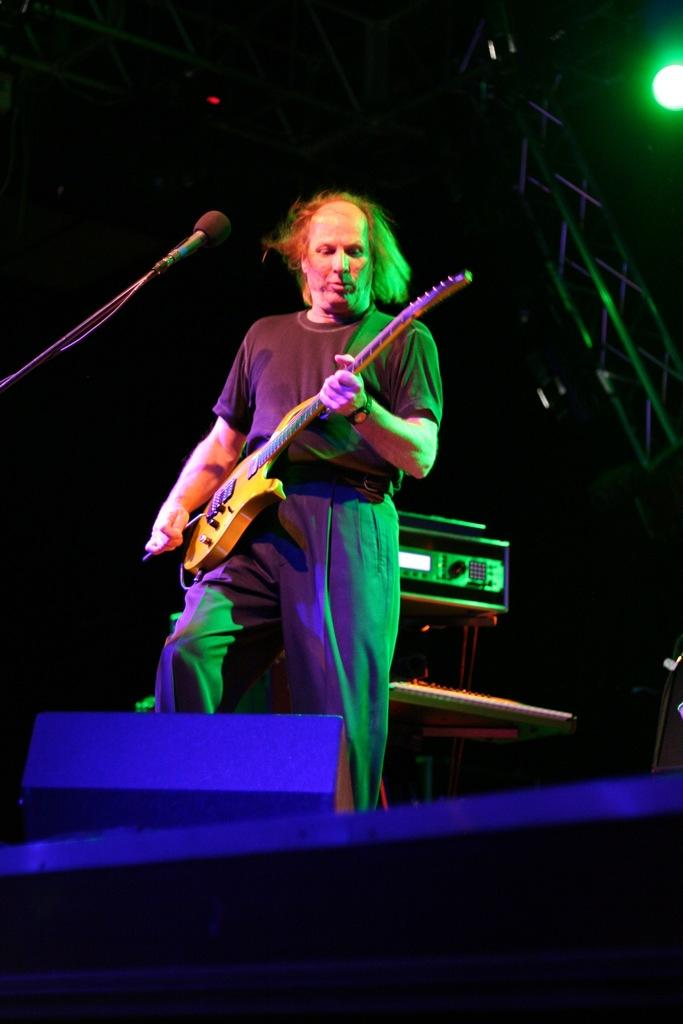Who is the main subject in the image? There is a guy in the image. What is the guy wearing? The guy is wearing a black dress. What is the guy holding in the image? The guy is holding a guitar. What is the guy doing with the guitar? The guy is playing the guitar. What is in front of the guy? There is a microphone in front of the guy. What can be seen in the background of the image? There is a musical instrument and a speaker in the background. How many friends are sitting on the chairs in the image? There are no chairs or friends present in the image. What type of sock is the guy wearing on his left foot in the image? The image does not show the guy's socks or feet, so it cannot be determined what type of sock he is wearing. 